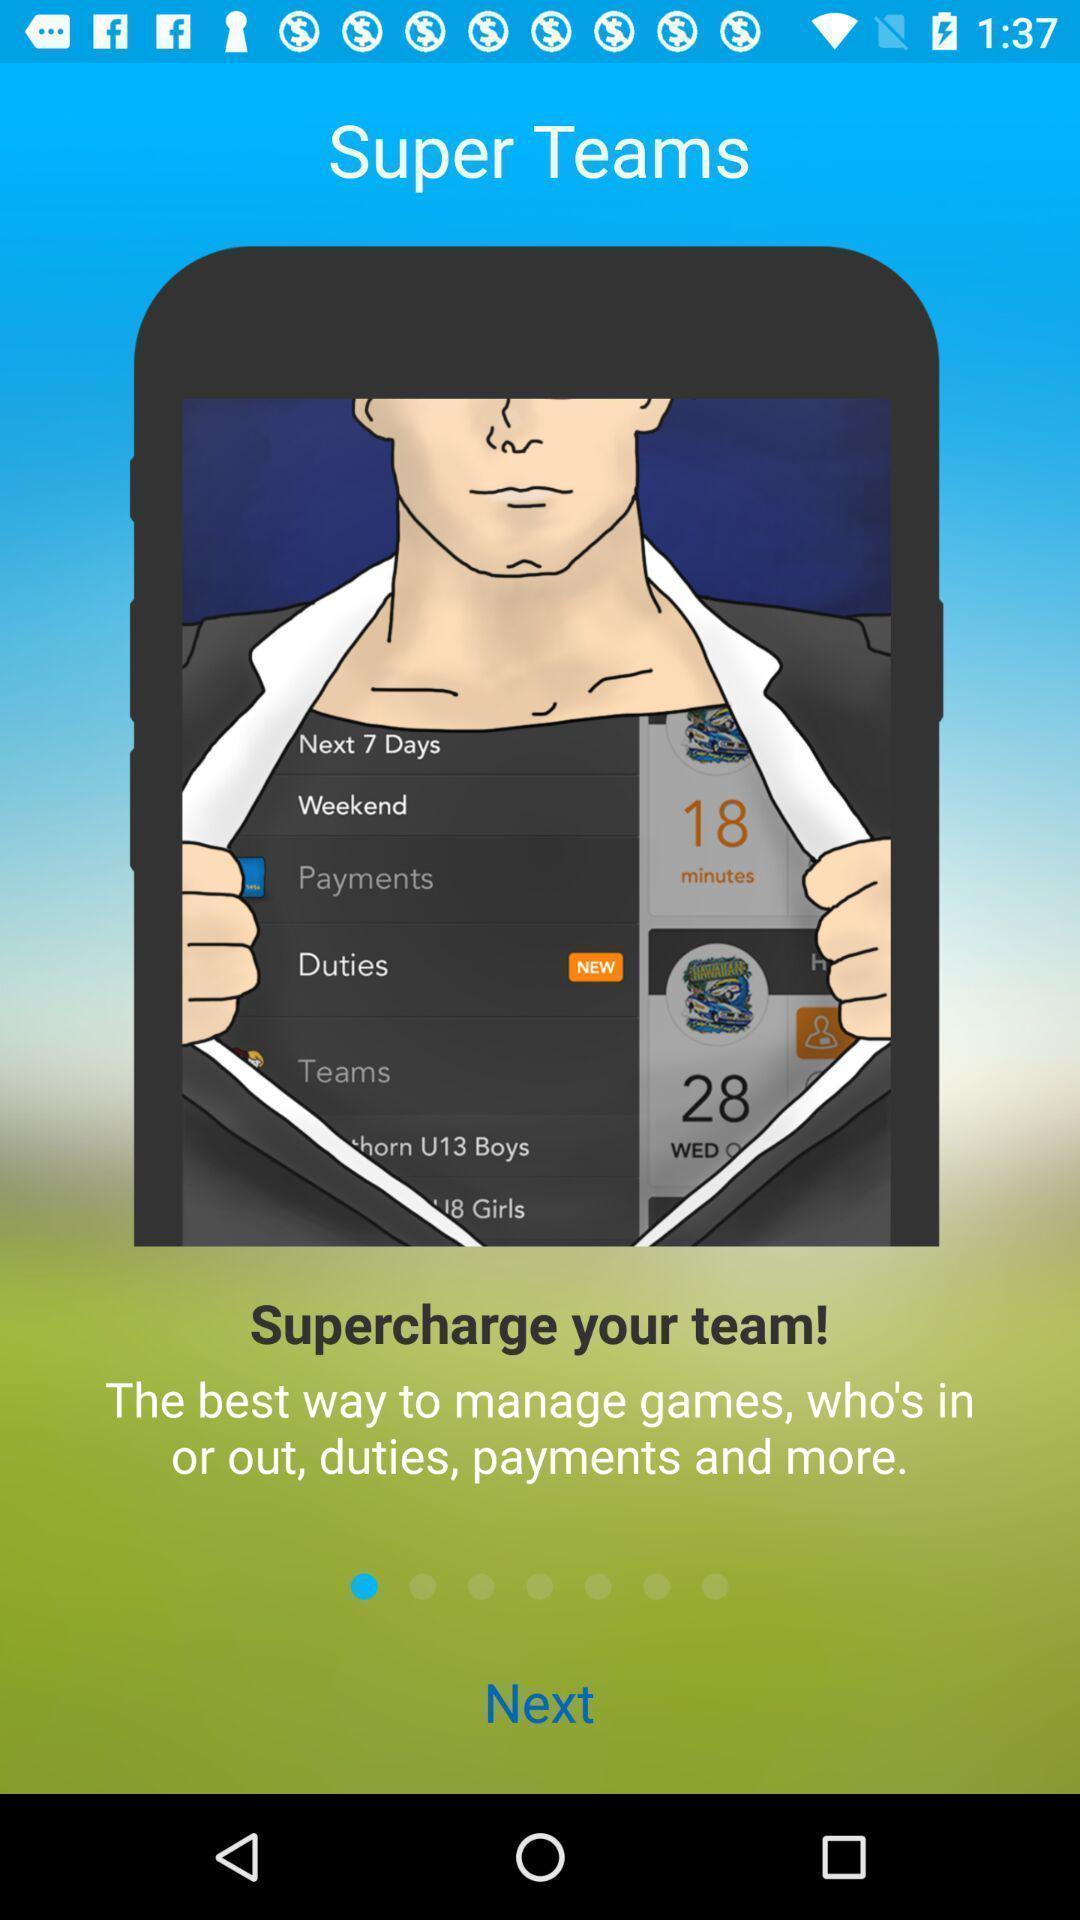Tell me what you see in this picture. Screen showing super teams. 